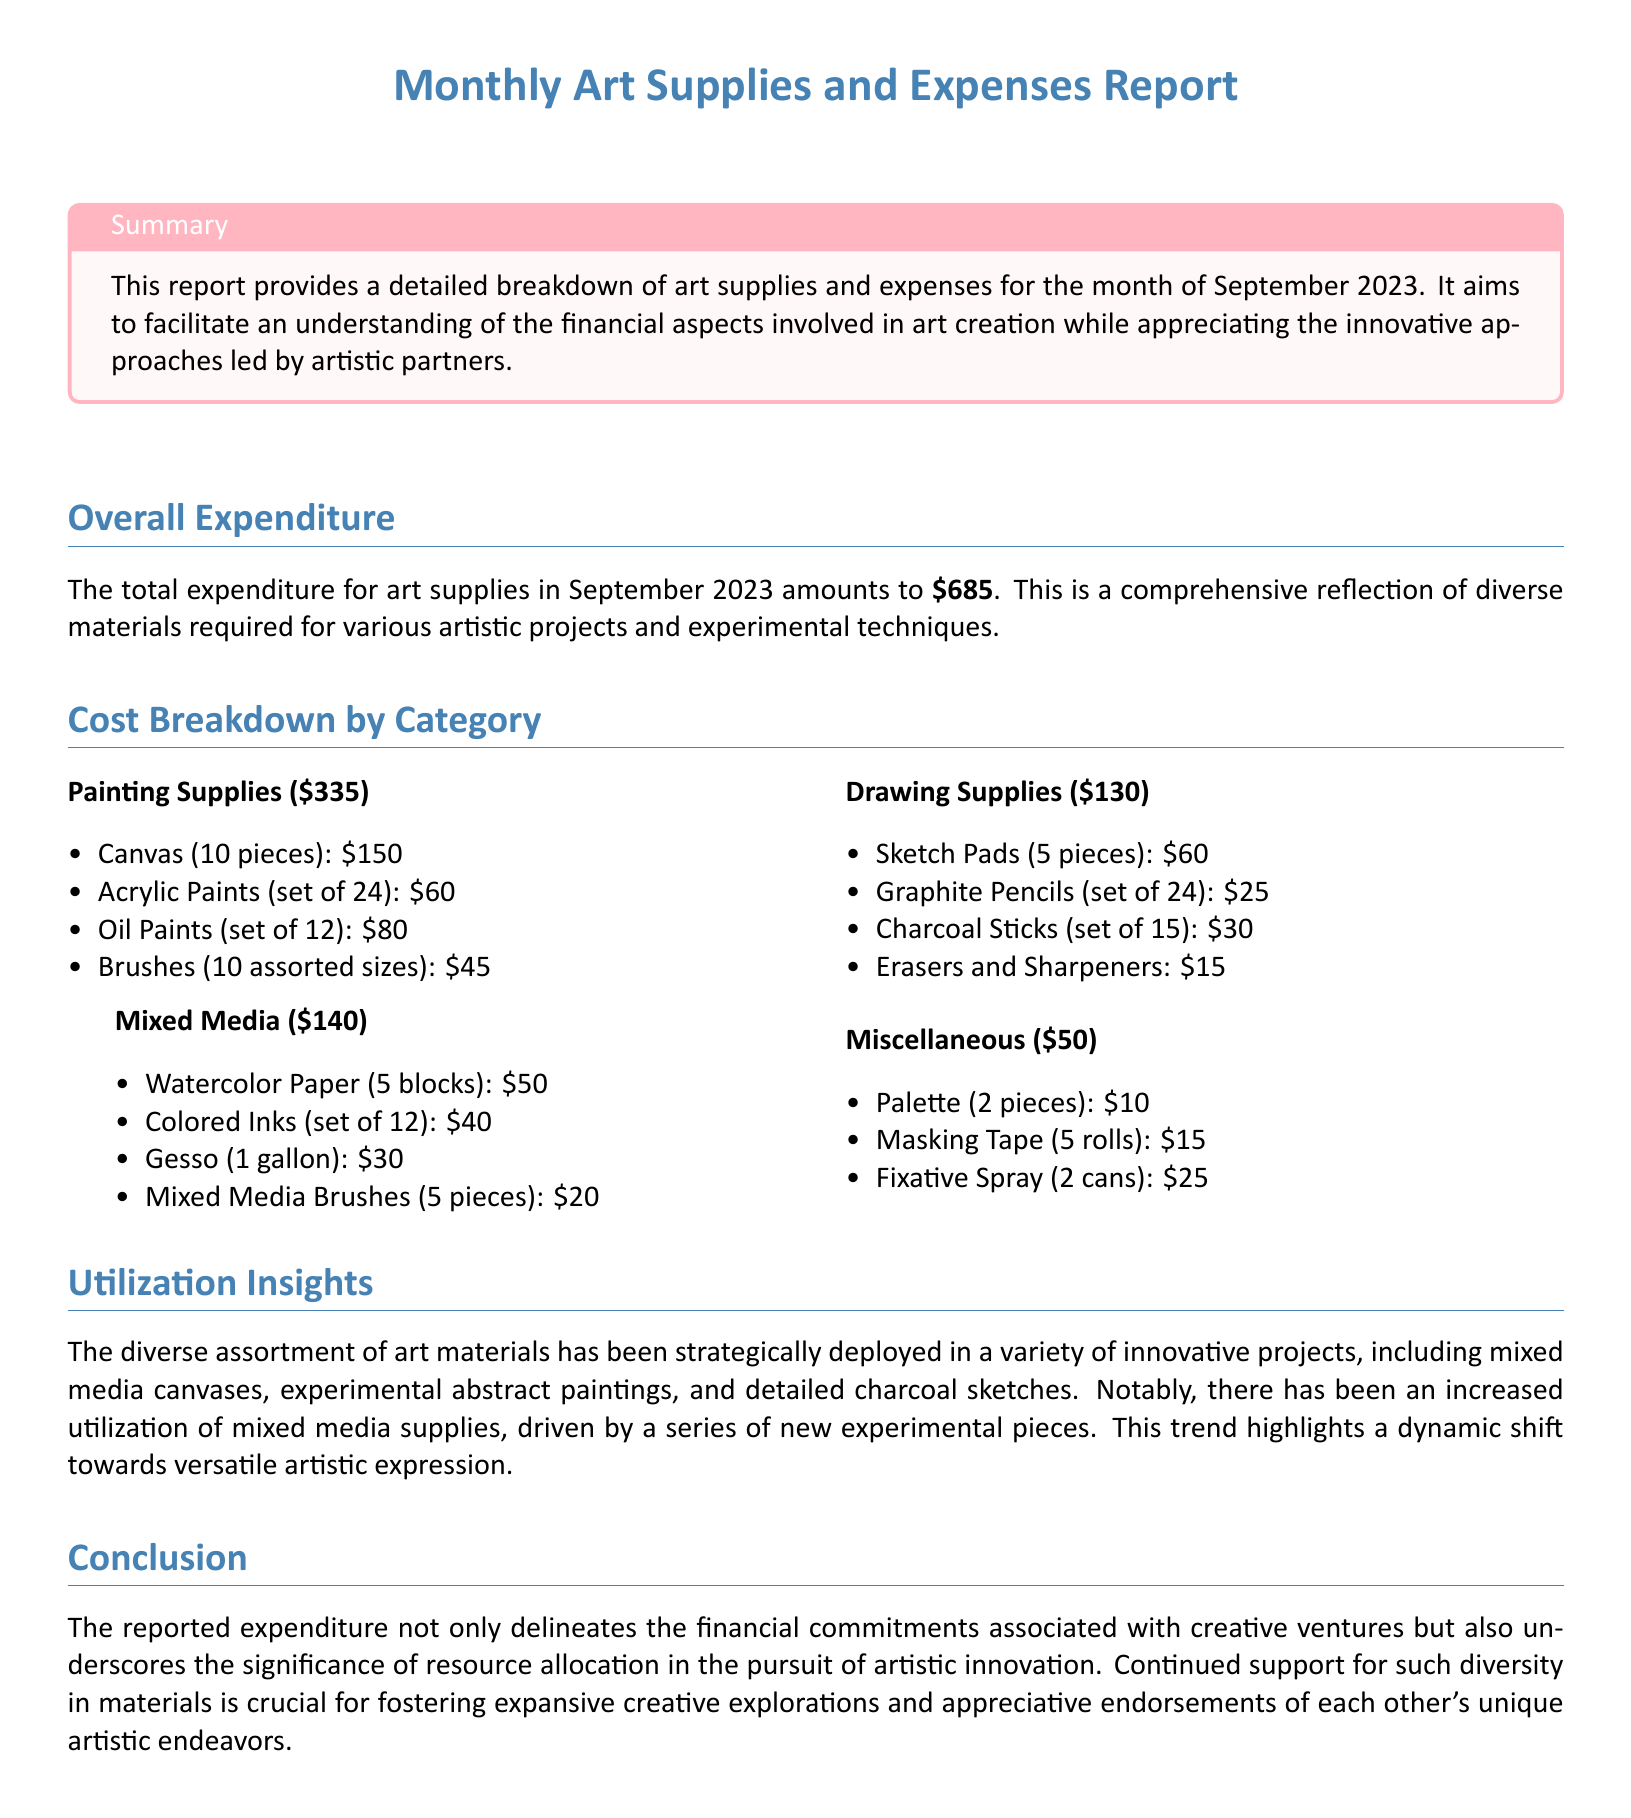what is the total expenditure for art supplies in September 2023? The total expenditure is explicitly stated in the document, which amounts to $685.
Answer: $685 how much was spent on painting supplies? The document provides a specific breakdown of costs, listing painting supplies as $335.
Answer: $335 what is the cost of brushes in the painting supplies section? The document details that the cost for brushes (10 assorted sizes) is $45.
Answer: $45 which category of supplies had the highest expenditure? By comparing the costs in the breakdown, painting supplies at $335 represent the highest expenditure.
Answer: Painting Supplies what is the total cost for drawing supplies? The total cost for drawing supplies is listed as $130 in the cost breakdown section.
Answer: $130 how many pieces of canvas were purchased? The document states that 10 pieces of canvas were included in the painting supplies.
Answer: 10 pieces what material saw increased utilization in this month's report? The document mentions that mixed media supplies saw an increased utilization due to new experimental pieces.
Answer: Mixed Media Supplies what is the purpose of this report? The summary section of the document describes the purpose as providing a breakdown of art supplies and expenses to understand financial aspects involved in art creation.
Answer: Understanding financial aspects which section contains information about miscellaneous expenses? The section labeled "Miscellaneous" contains information about miscellaneous expenses.
Answer: Miscellaneous 